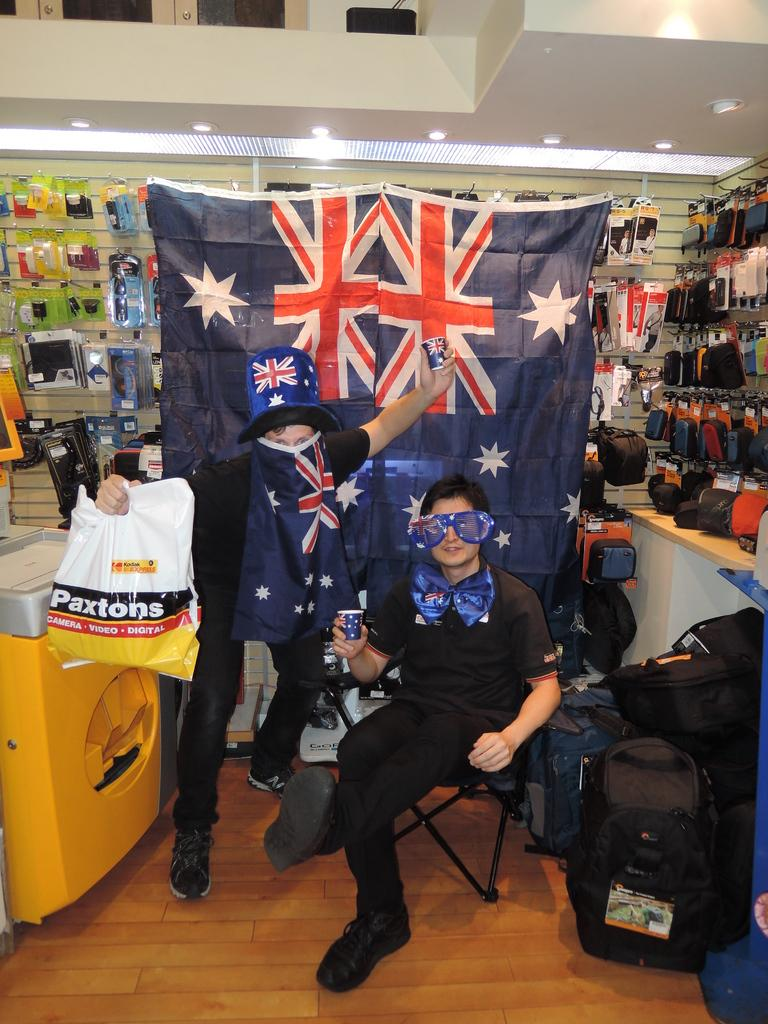<image>
Describe the image concisely. Men are posing in front of flags holding a Paxtons bag. 